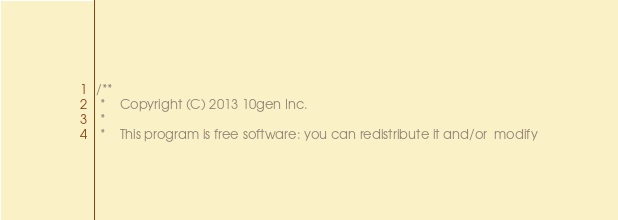Convert code to text. <code><loc_0><loc_0><loc_500><loc_500><_C_>/**
 *    Copyright (C) 2013 10gen Inc.
 *
 *    This program is free software: you can redistribute it and/or  modify</code> 